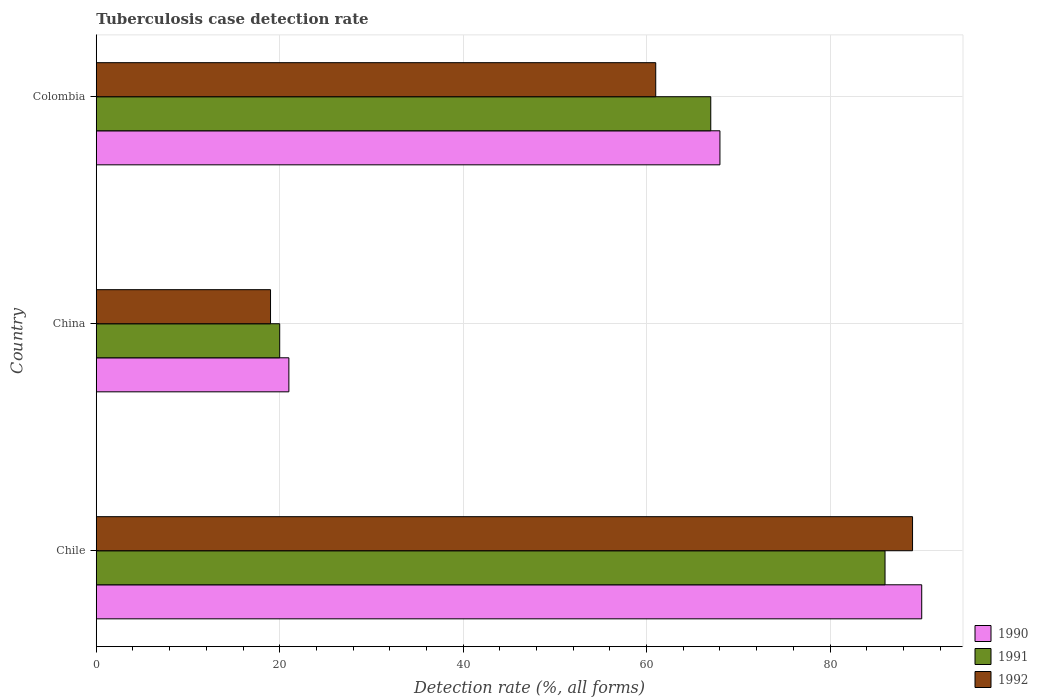How many bars are there on the 2nd tick from the top?
Provide a succinct answer. 3. What is the label of the 2nd group of bars from the top?
Offer a very short reply. China. Across all countries, what is the maximum tuberculosis case detection rate in in 1992?
Provide a short and direct response. 89. In which country was the tuberculosis case detection rate in in 1992 maximum?
Your response must be concise. Chile. In which country was the tuberculosis case detection rate in in 1992 minimum?
Your response must be concise. China. What is the total tuberculosis case detection rate in in 1991 in the graph?
Your answer should be very brief. 173. What is the difference between the tuberculosis case detection rate in in 1990 in China and that in Colombia?
Make the answer very short. -47. What is the average tuberculosis case detection rate in in 1990 per country?
Offer a very short reply. 59.67. What is the ratio of the tuberculosis case detection rate in in 1990 in Chile to that in Colombia?
Ensure brevity in your answer.  1.32. Is the tuberculosis case detection rate in in 1991 in Chile less than that in China?
Offer a terse response. No. Is the difference between the tuberculosis case detection rate in in 1990 in Chile and Colombia greater than the difference between the tuberculosis case detection rate in in 1991 in Chile and Colombia?
Make the answer very short. Yes. What is the difference between the highest and the lowest tuberculosis case detection rate in in 1992?
Keep it short and to the point. 70. Is the sum of the tuberculosis case detection rate in in 1991 in China and Colombia greater than the maximum tuberculosis case detection rate in in 1992 across all countries?
Provide a short and direct response. No. What does the 2nd bar from the bottom in China represents?
Offer a very short reply. 1991. Are all the bars in the graph horizontal?
Provide a short and direct response. Yes. How many countries are there in the graph?
Offer a very short reply. 3. What is the difference between two consecutive major ticks on the X-axis?
Offer a very short reply. 20. How many legend labels are there?
Keep it short and to the point. 3. What is the title of the graph?
Your answer should be compact. Tuberculosis case detection rate. What is the label or title of the X-axis?
Provide a succinct answer. Detection rate (%, all forms). What is the Detection rate (%, all forms) of 1992 in Chile?
Give a very brief answer. 89. What is the Detection rate (%, all forms) in 1992 in China?
Your answer should be very brief. 19. What is the Detection rate (%, all forms) in 1990 in Colombia?
Ensure brevity in your answer.  68. What is the Detection rate (%, all forms) in 1991 in Colombia?
Offer a very short reply. 67. Across all countries, what is the maximum Detection rate (%, all forms) of 1990?
Your response must be concise. 90. Across all countries, what is the maximum Detection rate (%, all forms) in 1991?
Your answer should be very brief. 86. Across all countries, what is the maximum Detection rate (%, all forms) of 1992?
Provide a short and direct response. 89. Across all countries, what is the minimum Detection rate (%, all forms) in 1990?
Your answer should be compact. 21. Across all countries, what is the minimum Detection rate (%, all forms) in 1992?
Make the answer very short. 19. What is the total Detection rate (%, all forms) in 1990 in the graph?
Provide a short and direct response. 179. What is the total Detection rate (%, all forms) in 1991 in the graph?
Your answer should be compact. 173. What is the total Detection rate (%, all forms) in 1992 in the graph?
Make the answer very short. 169. What is the difference between the Detection rate (%, all forms) of 1990 in Chile and that in China?
Make the answer very short. 69. What is the difference between the Detection rate (%, all forms) of 1990 in Chile and that in Colombia?
Provide a succinct answer. 22. What is the difference between the Detection rate (%, all forms) of 1991 in Chile and that in Colombia?
Ensure brevity in your answer.  19. What is the difference between the Detection rate (%, all forms) of 1990 in China and that in Colombia?
Ensure brevity in your answer.  -47. What is the difference between the Detection rate (%, all forms) in 1991 in China and that in Colombia?
Give a very brief answer. -47. What is the difference between the Detection rate (%, all forms) in 1992 in China and that in Colombia?
Your response must be concise. -42. What is the difference between the Detection rate (%, all forms) in 1990 in Chile and the Detection rate (%, all forms) in 1991 in China?
Make the answer very short. 70. What is the difference between the Detection rate (%, all forms) of 1991 in Chile and the Detection rate (%, all forms) of 1992 in China?
Offer a terse response. 67. What is the difference between the Detection rate (%, all forms) in 1990 in Chile and the Detection rate (%, all forms) in 1991 in Colombia?
Make the answer very short. 23. What is the difference between the Detection rate (%, all forms) in 1990 in Chile and the Detection rate (%, all forms) in 1992 in Colombia?
Your answer should be compact. 29. What is the difference between the Detection rate (%, all forms) in 1990 in China and the Detection rate (%, all forms) in 1991 in Colombia?
Make the answer very short. -46. What is the difference between the Detection rate (%, all forms) of 1991 in China and the Detection rate (%, all forms) of 1992 in Colombia?
Ensure brevity in your answer.  -41. What is the average Detection rate (%, all forms) of 1990 per country?
Offer a very short reply. 59.67. What is the average Detection rate (%, all forms) of 1991 per country?
Give a very brief answer. 57.67. What is the average Detection rate (%, all forms) in 1992 per country?
Provide a short and direct response. 56.33. What is the difference between the Detection rate (%, all forms) in 1991 and Detection rate (%, all forms) in 1992 in Chile?
Your answer should be compact. -3. What is the difference between the Detection rate (%, all forms) in 1991 and Detection rate (%, all forms) in 1992 in China?
Provide a short and direct response. 1. What is the difference between the Detection rate (%, all forms) of 1990 and Detection rate (%, all forms) of 1991 in Colombia?
Provide a succinct answer. 1. What is the ratio of the Detection rate (%, all forms) in 1990 in Chile to that in China?
Keep it short and to the point. 4.29. What is the ratio of the Detection rate (%, all forms) of 1991 in Chile to that in China?
Offer a terse response. 4.3. What is the ratio of the Detection rate (%, all forms) of 1992 in Chile to that in China?
Offer a very short reply. 4.68. What is the ratio of the Detection rate (%, all forms) of 1990 in Chile to that in Colombia?
Provide a short and direct response. 1.32. What is the ratio of the Detection rate (%, all forms) of 1991 in Chile to that in Colombia?
Your answer should be compact. 1.28. What is the ratio of the Detection rate (%, all forms) in 1992 in Chile to that in Colombia?
Your answer should be compact. 1.46. What is the ratio of the Detection rate (%, all forms) of 1990 in China to that in Colombia?
Your response must be concise. 0.31. What is the ratio of the Detection rate (%, all forms) in 1991 in China to that in Colombia?
Offer a very short reply. 0.3. What is the ratio of the Detection rate (%, all forms) of 1992 in China to that in Colombia?
Keep it short and to the point. 0.31. What is the difference between the highest and the second highest Detection rate (%, all forms) in 1990?
Make the answer very short. 22. What is the difference between the highest and the second highest Detection rate (%, all forms) in 1992?
Make the answer very short. 28. What is the difference between the highest and the lowest Detection rate (%, all forms) of 1992?
Your response must be concise. 70. 